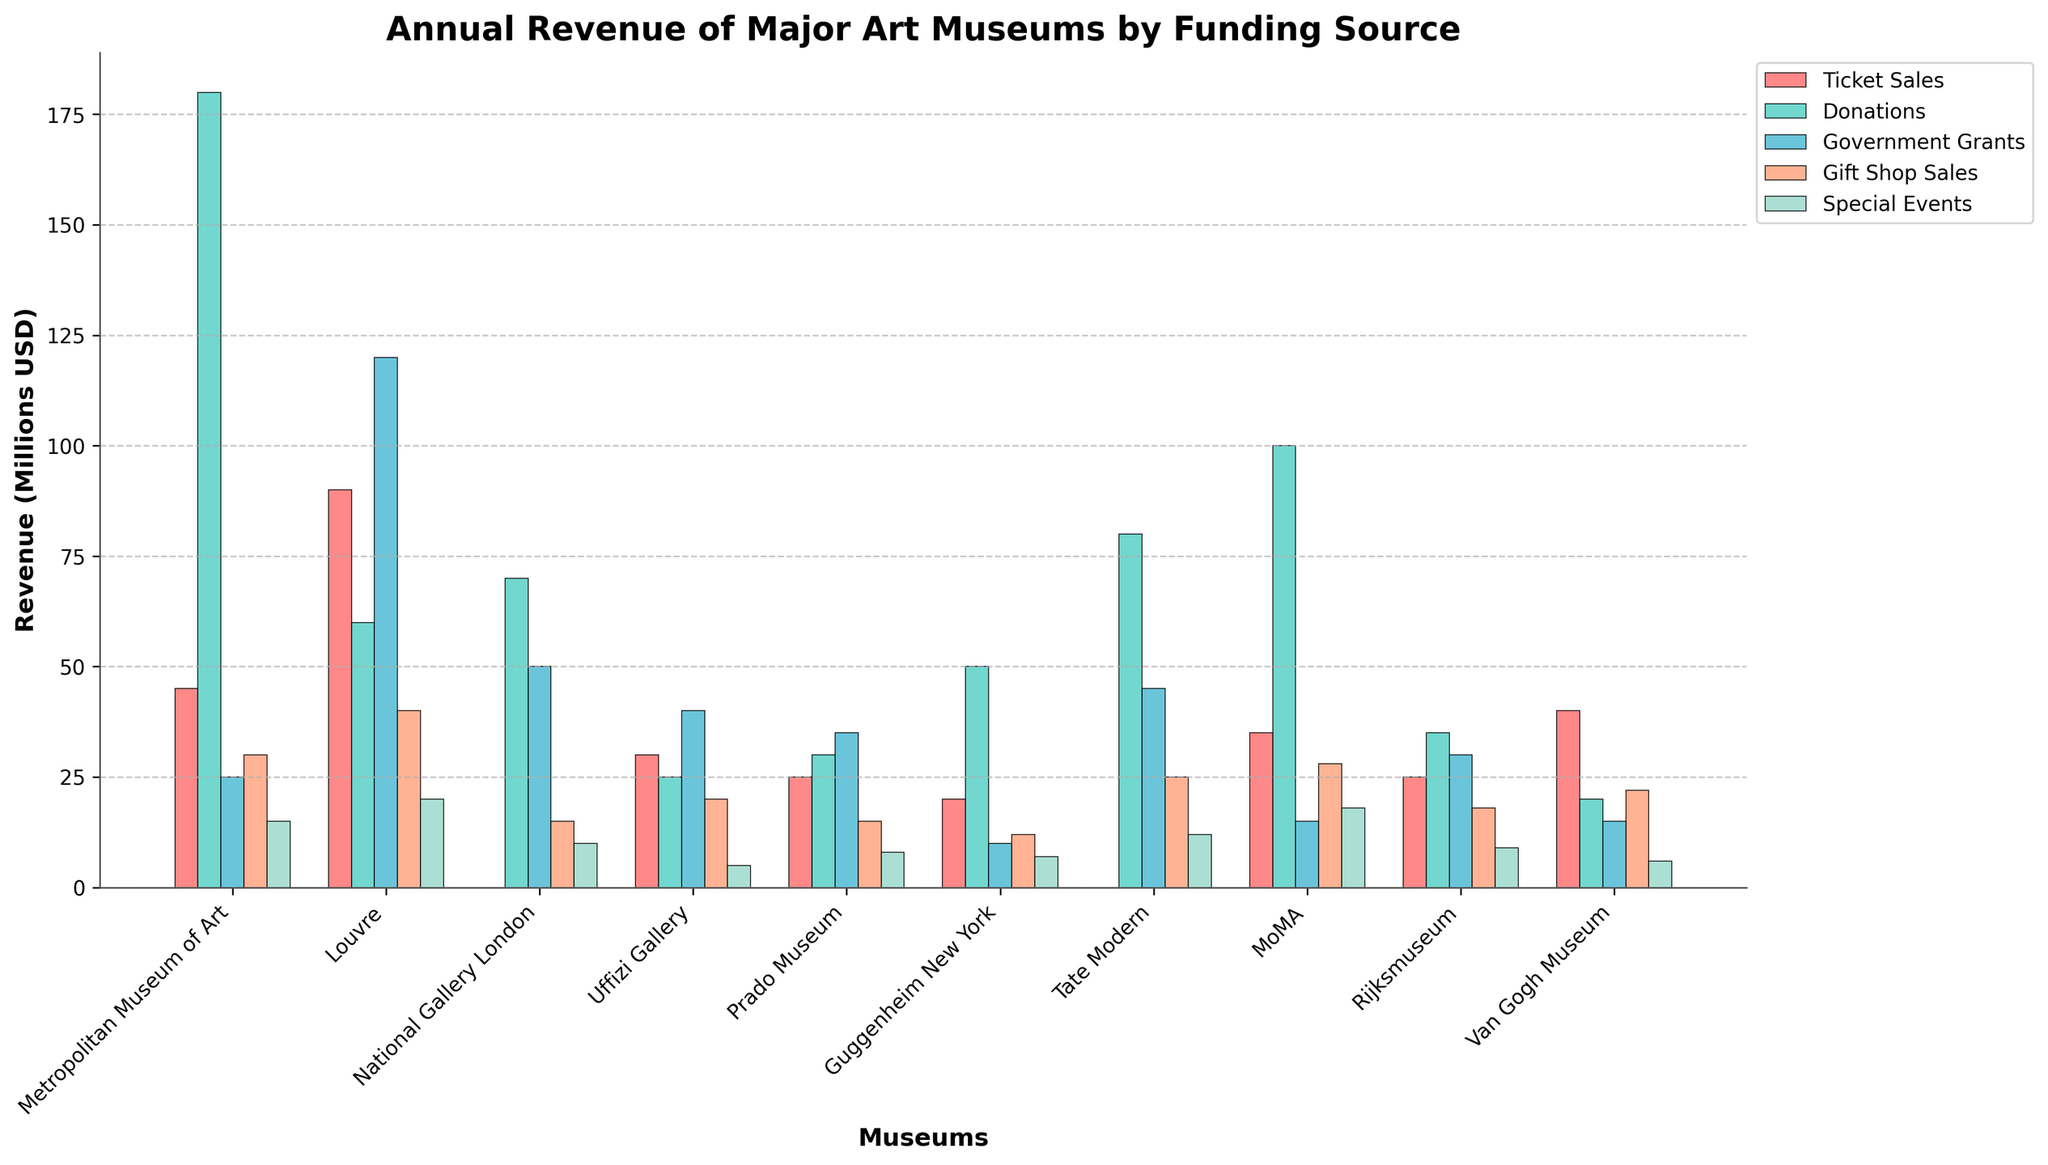Which museum generates the highest revenue from ticket sales? The museum with the highest bar for the "Ticket Sales" category will be the one generating the highest revenue from this source. The Louvre shows the tallest bar for ticket sales.
Answer: Louvre Between the Prado Museum and the Van Gogh Museum, which one has higher revenue from donations? Compare the heights of the bars for "Donations" between the Prado Museum and the Van Gogh Museum. The Prado Museum's bar is taller.
Answer: Prado Museum What is the total revenue generated by the Metropolitan Museum of Art from donations and government grants? Add the values for donations ($180,000,000) and government grants ($25,000,000) for the Metropolitan Museum of Art. The sum is $205,000,000.
Answer: $205 million Which funding source contributes the least to the National Gallery London's revenue? Identify the shortest bar for the National Gallery London across the different funding sources. The shortest bar corresponds to the "Special Events" category.
Answer: Special Events How much more revenue does the MoMA generate from ticket sales compared to the Guggenheim New York? Subtract the ticket sales revenue of the Guggenheim New York ($20,000,000) from that of the MoMA ($35,000,000). The difference is $15,000,000.
Answer: $15 million Which museum has the greatest total revenue when combining ticket sales and gift shop sales? Add the values for ticket sales and gift shop sales for each museum and compare the sums. The Louvre has the greatest total ($90,000,000 + $40,000,000 = $130,000,000).
Answer: Louvre Is the revenue from special events higher for the Tate Modern or the Prado Museum? Compare the heights of the bars for "Special Events" for the Tate Modern and the Prado Museum. The Tate Modern has a taller bar.
Answer: Tate Modern What is the total revenue from government grants for all museums combined? Add the government grants amounts for all museums:
$25,000,000 (Metropolitan) + $120,000,000 (Louvre) + $50,000,000 (National Gallery) + $40,000,000 (Uffizi) + $35,000,000 (Prado) + $10,000,000 (Guggenheim) + $45,000,000 (Tate) + $15,000,000 (MoMA) + $30,000,000 (Rijksmuseum) + $15,000,000 (Van Gogh) = $385,000,000.
Answer: $385 million Between the Rijksmuseum and the Metropolitan Museum of Art, which one has higher total revenue from gift shop sales and special events? Add the revenue from gift shop sales and special events for each museum and compare:
Rijksmuseum: $18,000,000 + $9,000,000 = $27,000,000,
Metropolitan Museum of Art: $30,000,000 + $15,000,000 = $45,000,000.
The Metropolitan Museum of Art has higher revenue.
Answer: Metropolitan Museum of Art Which museum has the highest combined revenue from all funding sources? Sum the revenue from all sources for each museum and find the highest sum:
Metropolitan Museum of Art: $45,000,000 + $180,000,000 + $25,000,000 + $30,000,000 + $15,000,000 = $295,000,000,
Louvre: $90,000,000 + $60,000,000 + $120,000,000 + $40,000,000 + $20,000,000 = $330,000,000,
National Gallery London: $0 + $70,000,000 + $50,000,000 + $15,000,000 + $10,000,000 = $145,000,000,
Uffizi Gallery: $30,000,000 + $25,000,000 + $40,000,000 + $20,000,000 + $5,000,000 = $120,000,000,
Prado Museum: $25,000,000 + $30,000,000 + $35,000,000 + $15,000,000 + $8,000,000 = $113,000,000,
Guggenheim New York: $20,000,000 + $50,000,000 + $10,000,000 + $12,000,000 + $7,000,000 = $99,000,000,
Tate Modern: $0 + $80,000,000 + $45,000,000 + $25,000,000 + $12,000,000 = $162,000,000,
MoMA: $35,000,000 + $100,000,000 + $15,000,000 + $28,000,000 + $18,000,000 = $196,000,000,
Rijksmuseum: $25,000,000 + $35,000,000 + $30,000,000 + $18,000,000 + $9,000,000 = $117,000,000,
Van Gogh Museum: $40,000,000 + $20,000,000 + $15,000,000 + $22,000,000 + $6,000,000 = $103,000,000.
The Louvre has the highest combined revenue.
Answer: Louvre 